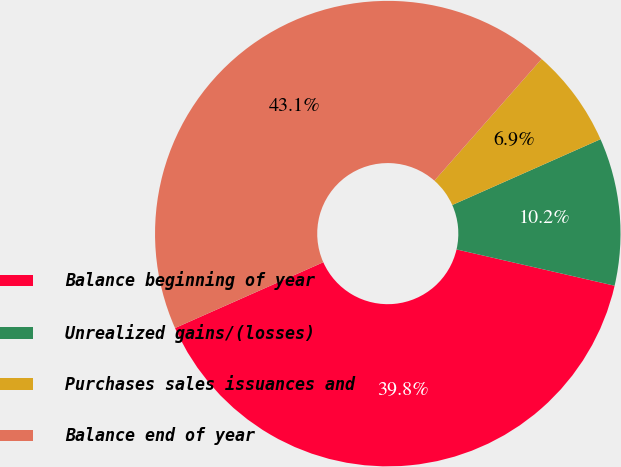<chart> <loc_0><loc_0><loc_500><loc_500><pie_chart><fcel>Balance beginning of year<fcel>Unrealized gains/(losses)<fcel>Purchases sales issuances and<fcel>Balance end of year<nl><fcel>39.76%<fcel>10.24%<fcel>6.86%<fcel>43.14%<nl></chart> 